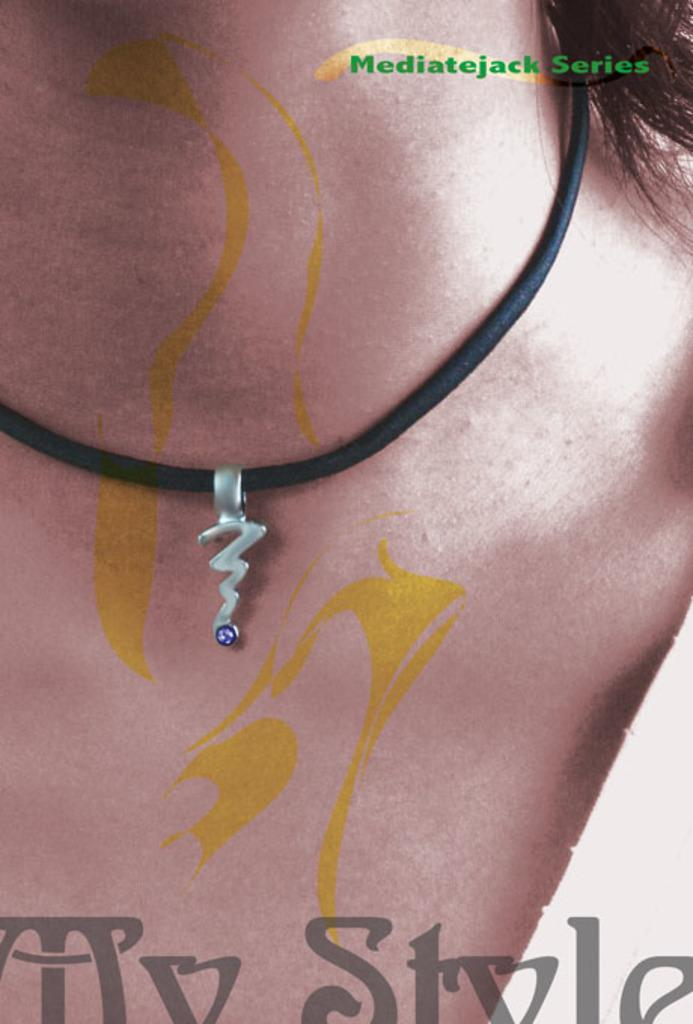Who is present in the image? There is a person in the image. What is the person wearing? The person is wearing a black rope. What does the person have in their possession? The person has a dollar. Is the parcel being delivered by the person in the image? There is no parcel present in the image. Who is the partner of the person in the image? The image does not show any other person, so it is impossible to determine the person's partner. 